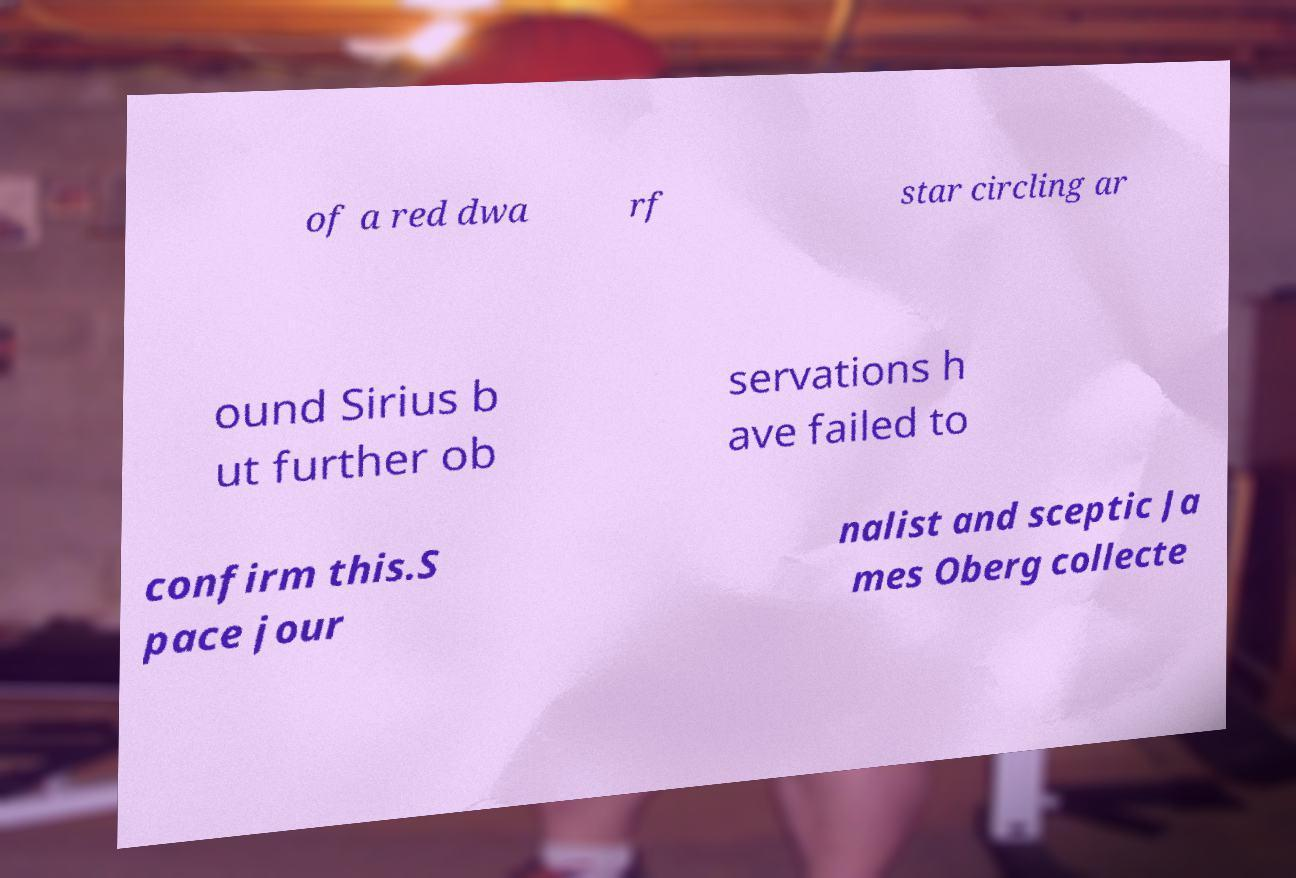Please read and relay the text visible in this image. What does it say? of a red dwa rf star circling ar ound Sirius b ut further ob servations h ave failed to confirm this.S pace jour nalist and sceptic Ja mes Oberg collecte 